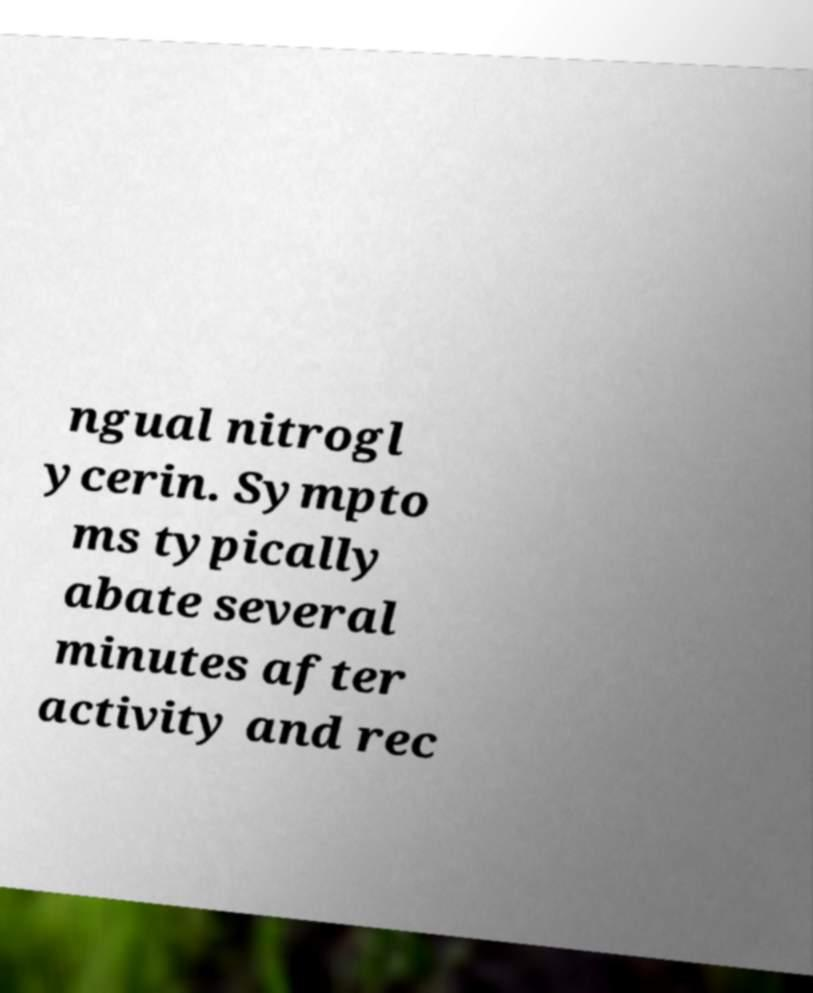Could you assist in decoding the text presented in this image and type it out clearly? ngual nitrogl ycerin. Sympto ms typically abate several minutes after activity and rec 